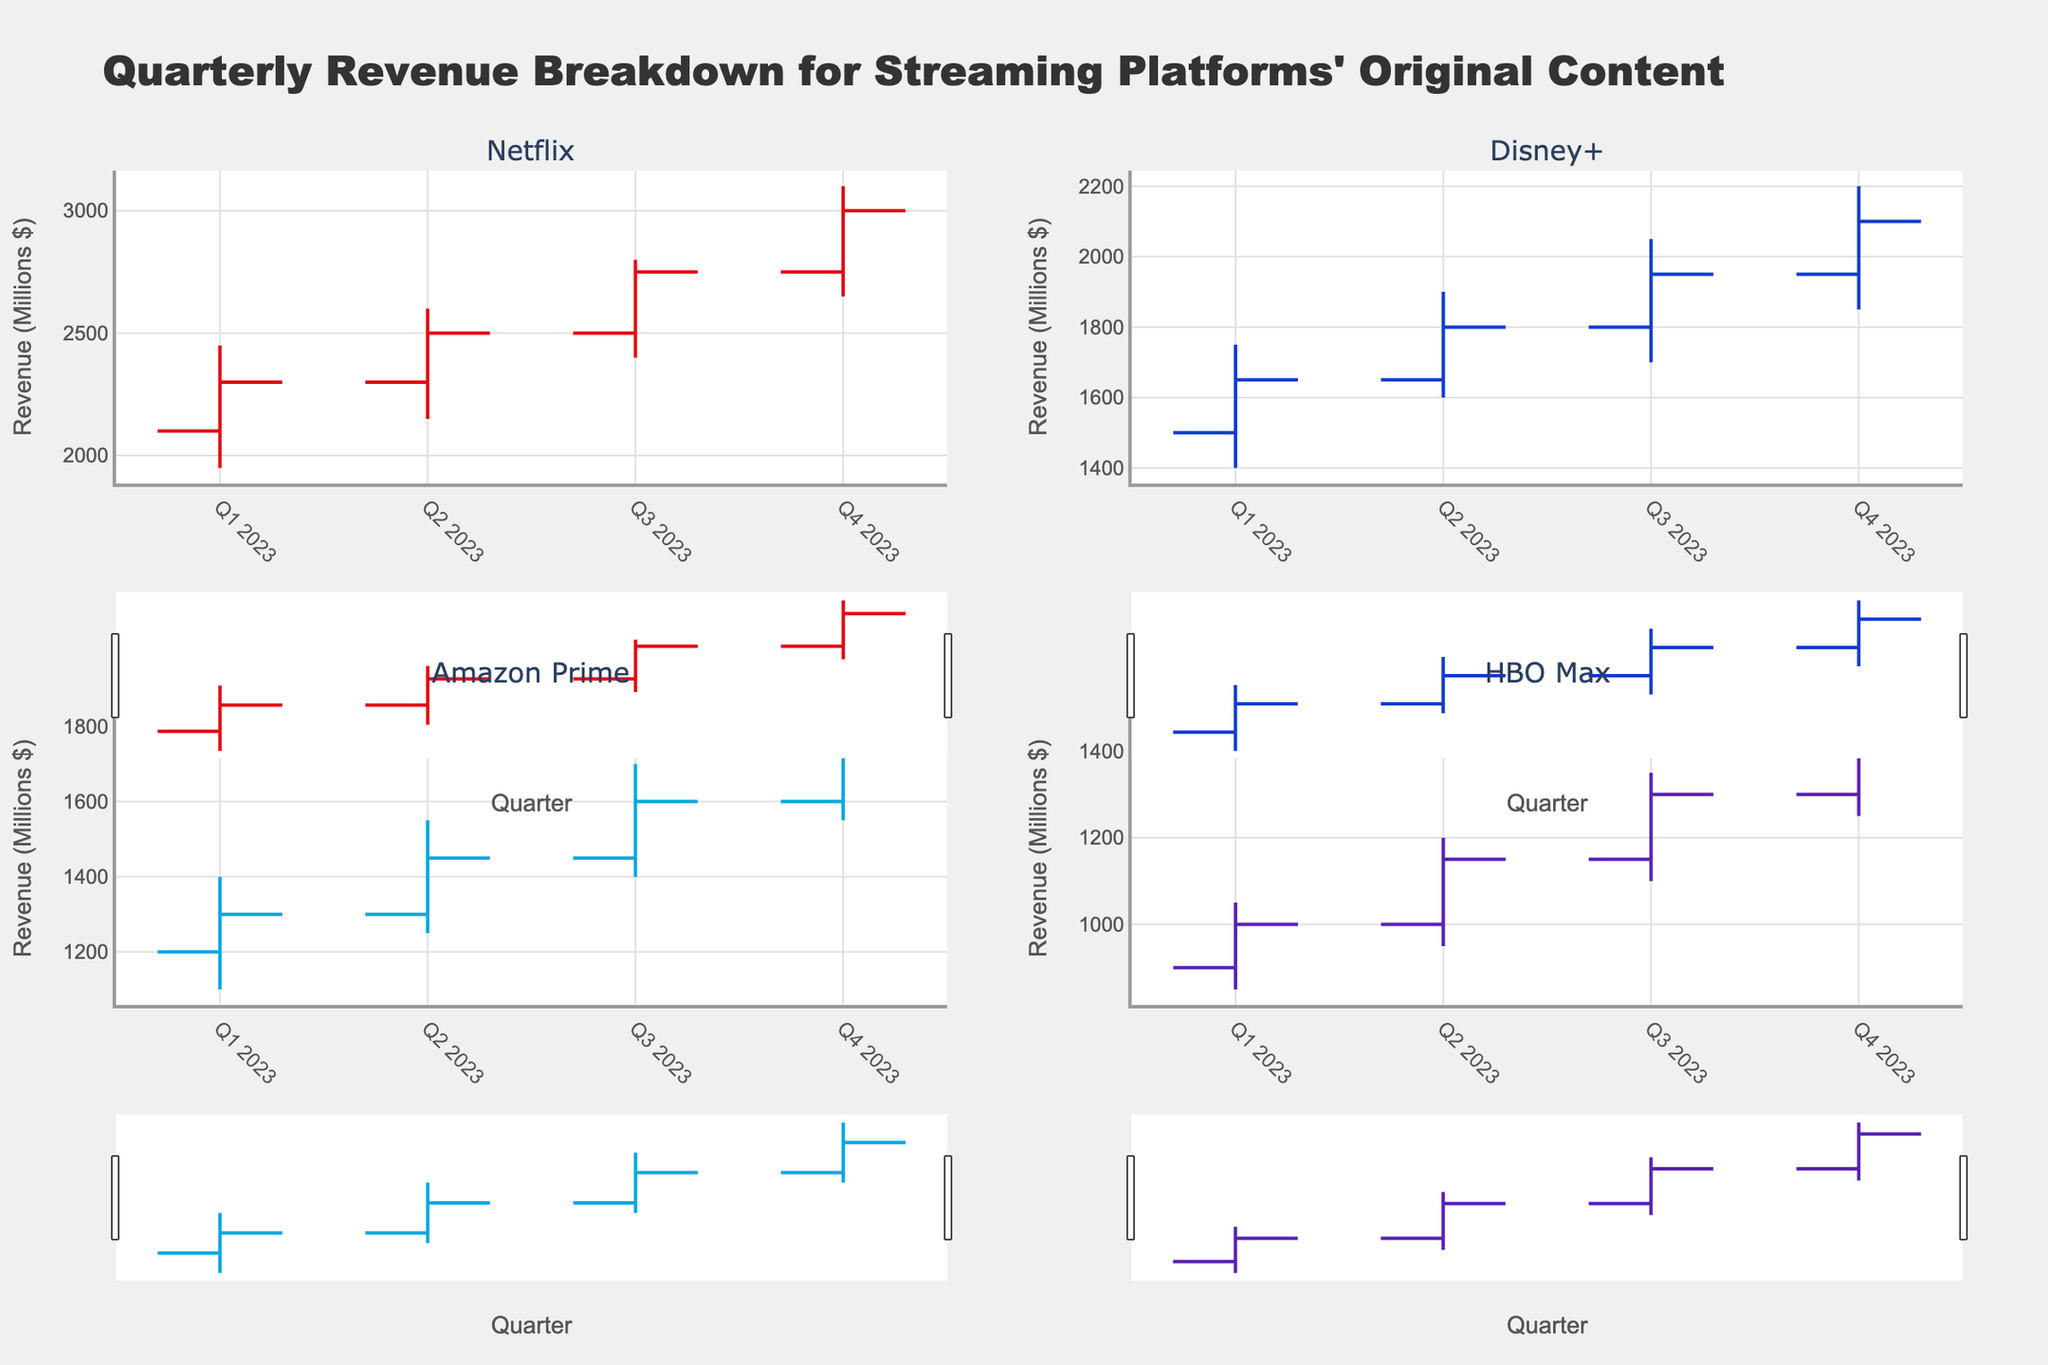what is the title of the chart? The title of the chart is shown at the top, stating “Quarterly Revenue Breakdown for Streaming Platforms' Original Content”.
Answer: Quarterly Revenue Breakdown for Streaming Platforms' Original Content For Netflix, what was the highest revenue reported in Q3 2023? The OHLC chart for Netflix shows the highest revenue value for Q3 2023 in the 'High' section, which is 2800 millions $
Answer: 2800 What is the overall trend in revenue for Disney+ from Q1 2023 to Q4 2023? Observing the OHLC chart for Disney+, the overall trend is identified by looking at the 'Open' and 'Close' values of each quarter. Disney+ shows an increasing trend in revenue from Q1 2023 to Q4 2023, starting from 1500 (Open) to 2100 (Close).
Answer: Increasing Which platform had the lowest revenue in Q1 2023? By comparing the 'Low' values for Q1 2023 across all platforms, HBO Max had the lowest revenue at 850 millions $.
Answer: HBO Max Did Amazon Prime's revenue ever decrease from one quarter to the next in 2023? Referencing Amazon Prime's 'Close' values across all quarters of 2023, the values continue to increase from one quarter to the next (1300, 1450, 1600, 1750). Hence, the revenue did not decrease.
Answer: No Compare the revenue changes between Netflix and Amazon Prime in terms of 'Open' and 'Close' values from Q1 2023 to Q4 2023. Which platform showed a higher net gain? Calculate the difference between 'Open' and 'Close' values for both platforms. Netflix: 3000 (Q4 Close) - 2100 (Q1 Open) = 900. Amazon Prime: 1750 (Q4 Close) - 1200 (Q1 Open) = 550. Netflix showed a higher net gain.
Answer: Netflix What is the range of revenue for HBO Max in Q2 2023? The range is determined by subtracting the 'Low' value from the 'High' value for HBO Max in Q2 2023. The calculation is 1200 (High) - 950 (Low) = 250 millions $.
Answer: 250 Was there any quarter where Netflix had a decrease in closing revenue compared to previous quarter? Look at the 'Close' values for Netflix from one quarter to the next. The closing revenues are: Q1 - 2300, Q2 - 2500, Q3 - 2750, Q4 - 3000. There was no decrease in the closing revenue in any quarter.
Answer: No 